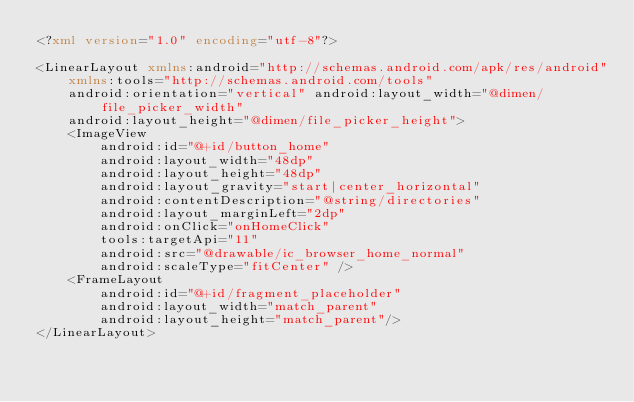Convert code to text. <code><loc_0><loc_0><loc_500><loc_500><_XML_><?xml version="1.0" encoding="utf-8"?>

<LinearLayout xmlns:android="http://schemas.android.com/apk/res/android"
    xmlns:tools="http://schemas.android.com/tools"
    android:orientation="vertical" android:layout_width="@dimen/file_picker_width"
    android:layout_height="@dimen/file_picker_height">
    <ImageView
        android:id="@+id/button_home"
        android:layout_width="48dp"
        android:layout_height="48dp"
        android:layout_gravity="start|center_horizontal"
        android:contentDescription="@string/directories"
        android:layout_marginLeft="2dp"
        android:onClick="onHomeClick"
        tools:targetApi="11"
        android:src="@drawable/ic_browser_home_normal"
        android:scaleType="fitCenter" />
    <FrameLayout
        android:id="@+id/fragment_placeholder"
        android:layout_width="match_parent"
        android:layout_height="match_parent"/>
</LinearLayout>
</code> 